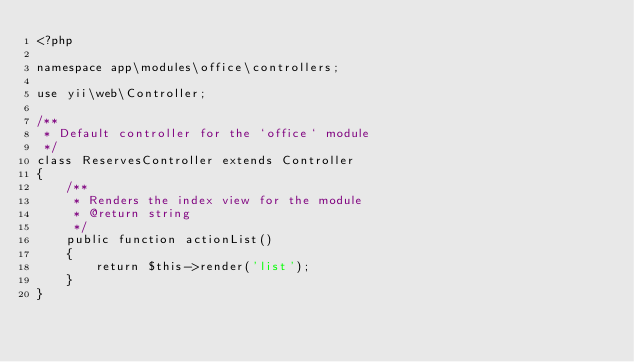Convert code to text. <code><loc_0><loc_0><loc_500><loc_500><_PHP_><?php

namespace app\modules\office\controllers;

use yii\web\Controller;

/**
 * Default controller for the `office` module
 */
class ReservesController extends Controller
{
    /**
     * Renders the index view for the module
     * @return string
     */
    public function actionList()
    {
        return $this->render('list');
    }
}
</code> 